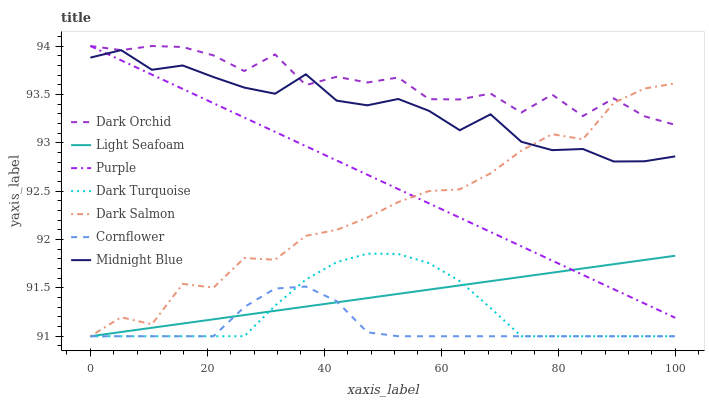Does Cornflower have the minimum area under the curve?
Answer yes or no. Yes. Does Dark Orchid have the maximum area under the curve?
Answer yes or no. Yes. Does Midnight Blue have the minimum area under the curve?
Answer yes or no. No. Does Midnight Blue have the maximum area under the curve?
Answer yes or no. No. Is Light Seafoam the smoothest?
Answer yes or no. Yes. Is Dark Orchid the roughest?
Answer yes or no. Yes. Is Midnight Blue the smoothest?
Answer yes or no. No. Is Midnight Blue the roughest?
Answer yes or no. No. Does Cornflower have the lowest value?
Answer yes or no. Yes. Does Midnight Blue have the lowest value?
Answer yes or no. No. Does Dark Orchid have the highest value?
Answer yes or no. Yes. Does Midnight Blue have the highest value?
Answer yes or no. No. Is Cornflower less than Midnight Blue?
Answer yes or no. Yes. Is Midnight Blue greater than Light Seafoam?
Answer yes or no. Yes. Does Cornflower intersect Light Seafoam?
Answer yes or no. Yes. Is Cornflower less than Light Seafoam?
Answer yes or no. No. Is Cornflower greater than Light Seafoam?
Answer yes or no. No. Does Cornflower intersect Midnight Blue?
Answer yes or no. No. 